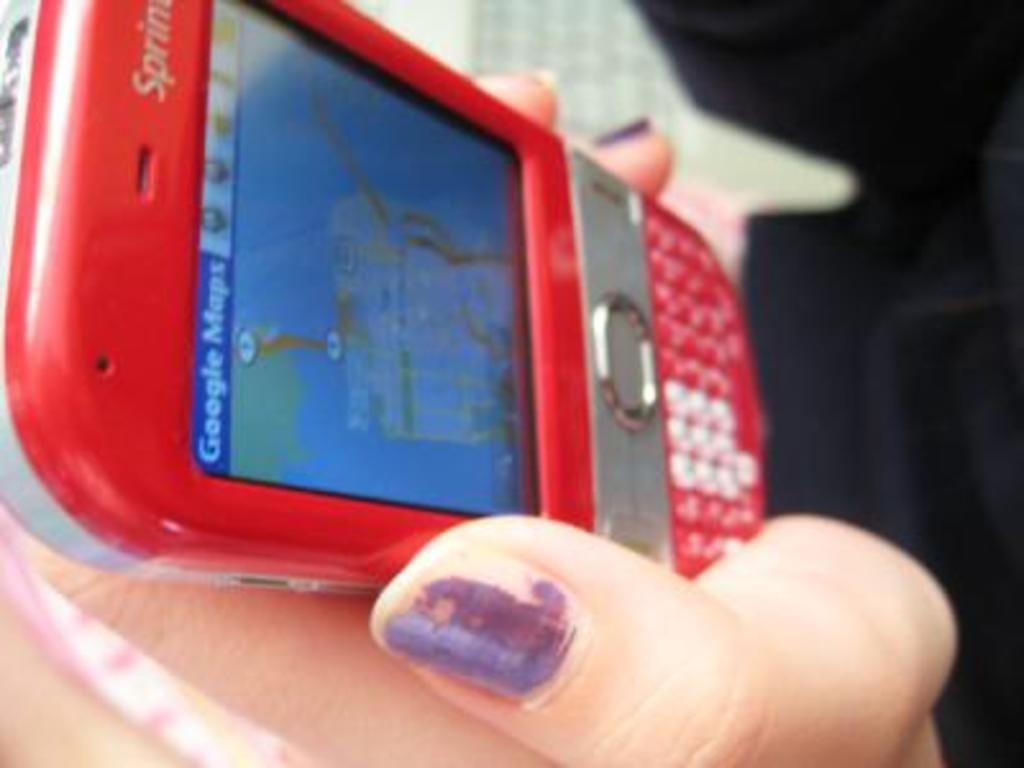<image>
Describe the image concisely. a lady interacting with Google Maps on the phone 